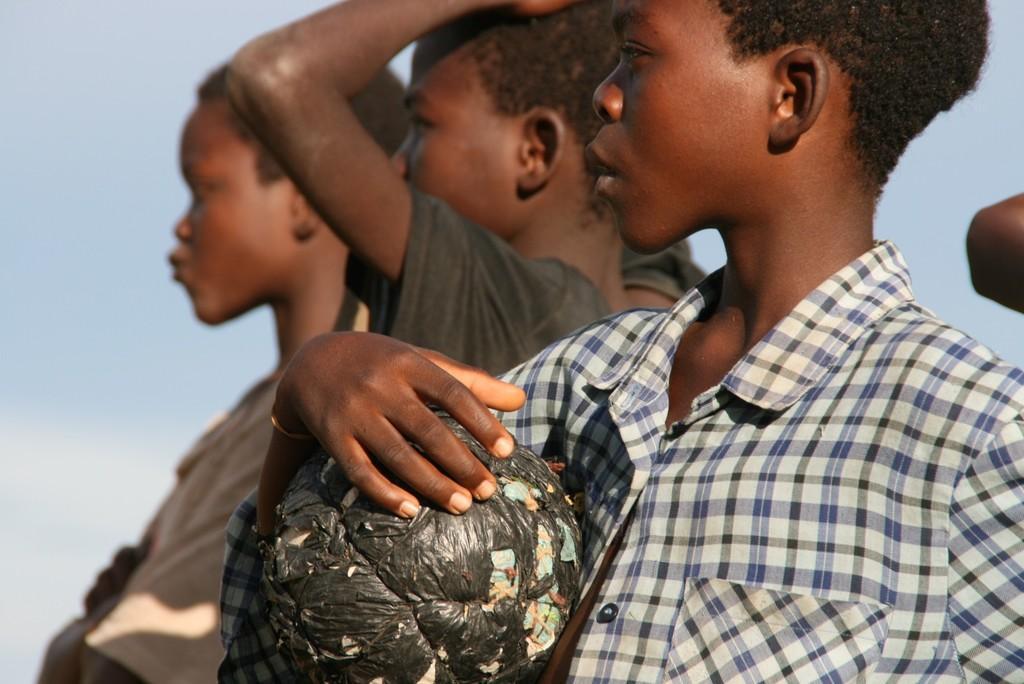Please provide a concise description of this image. In this image there are persons standing and the boy in the front is holding an object which is black in colour and the sky is cloudy. 